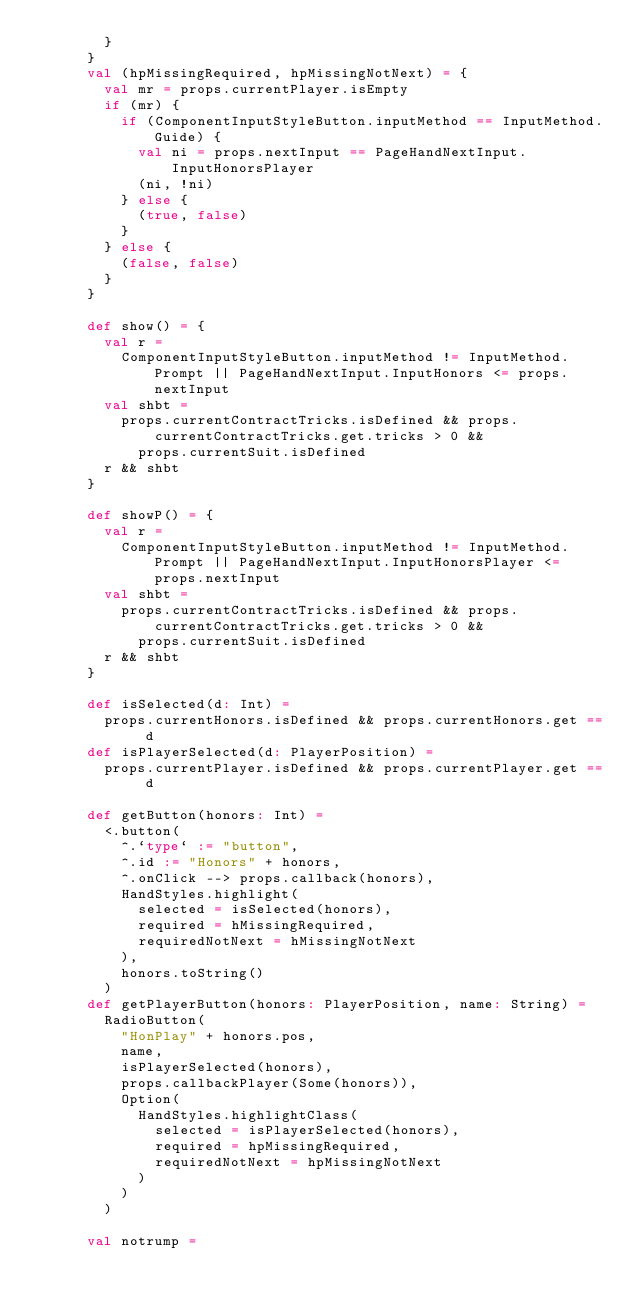<code> <loc_0><loc_0><loc_500><loc_500><_Scala_>        }
      }
      val (hpMissingRequired, hpMissingNotNext) = {
        val mr = props.currentPlayer.isEmpty
        if (mr) {
          if (ComponentInputStyleButton.inputMethod == InputMethod.Guide) {
            val ni = props.nextInput == PageHandNextInput.InputHonorsPlayer
            (ni, !ni)
          } else {
            (true, false)
          }
        } else {
          (false, false)
        }
      }

      def show() = {
        val r =
          ComponentInputStyleButton.inputMethod != InputMethod.Prompt || PageHandNextInput.InputHonors <= props.nextInput
        val shbt =
          props.currentContractTricks.isDefined && props.currentContractTricks.get.tricks > 0 &&
            props.currentSuit.isDefined
        r && shbt
      }

      def showP() = {
        val r =
          ComponentInputStyleButton.inputMethod != InputMethod.Prompt || PageHandNextInput.InputHonorsPlayer <= props.nextInput
        val shbt =
          props.currentContractTricks.isDefined && props.currentContractTricks.get.tricks > 0 &&
            props.currentSuit.isDefined
        r && shbt
      }

      def isSelected(d: Int) =
        props.currentHonors.isDefined && props.currentHonors.get == d
      def isPlayerSelected(d: PlayerPosition) =
        props.currentPlayer.isDefined && props.currentPlayer.get == d

      def getButton(honors: Int) =
        <.button(
          ^.`type` := "button",
          ^.id := "Honors" + honors,
          ^.onClick --> props.callback(honors),
          HandStyles.highlight(
            selected = isSelected(honors),
            required = hMissingRequired,
            requiredNotNext = hMissingNotNext
          ),
          honors.toString()
        )
      def getPlayerButton(honors: PlayerPosition, name: String) =
        RadioButton(
          "HonPlay" + honors.pos,
          name,
          isPlayerSelected(honors),
          props.callbackPlayer(Some(honors)),
          Option(
            HandStyles.highlightClass(
              selected = isPlayerSelected(honors),
              required = hpMissingRequired,
              requiredNotNext = hpMissingNotNext
            )
          )
        )

      val notrump =</code> 